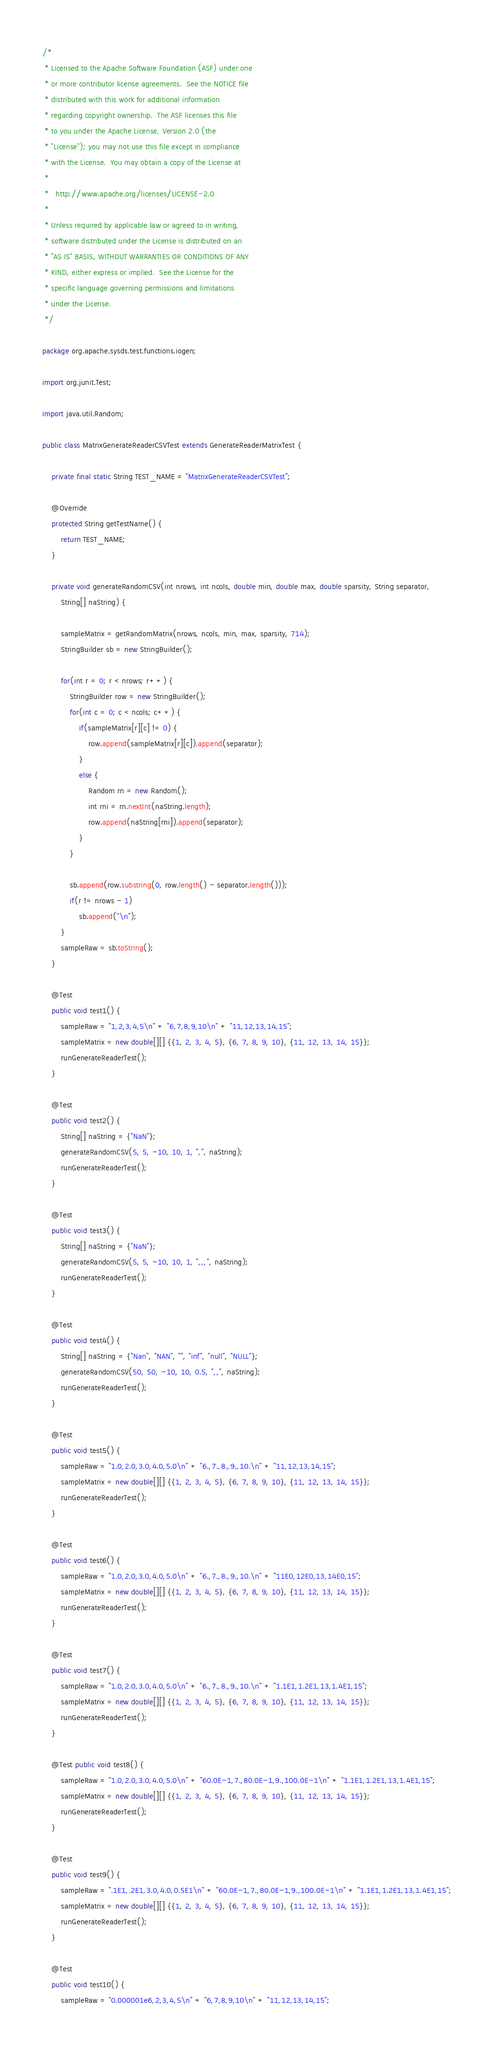Convert code to text. <code><loc_0><loc_0><loc_500><loc_500><_Java_>/*
 * Licensed to the Apache Software Foundation (ASF) under one
 * or more contributor license agreements.  See the NOTICE file
 * distributed with this work for additional information
 * regarding copyright ownership.  The ASF licenses this file
 * to you under the Apache License, Version 2.0 (the
 * "License"); you may not use this file except in compliance
 * with the License.  You may obtain a copy of the License at
 *
 *   http://www.apache.org/licenses/LICENSE-2.0
 *
 * Unless required by applicable law or agreed to in writing,
 * software distributed under the License is distributed on an
 * "AS IS" BASIS, WITHOUT WARRANTIES OR CONDITIONS OF ANY
 * KIND, either express or implied.  See the License for the
 * specific language governing permissions and limitations
 * under the License.
 */

package org.apache.sysds.test.functions.iogen;

import org.junit.Test;

import java.util.Random;

public class MatrixGenerateReaderCSVTest extends GenerateReaderMatrixTest {

	private final static String TEST_NAME = "MatrixGenerateReaderCSVTest";

	@Override
	protected String getTestName() {
		return TEST_NAME;
	}

	private void generateRandomCSV(int nrows, int ncols, double min, double max, double sparsity, String separator,
		String[] naString) {

		sampleMatrix = getRandomMatrix(nrows, ncols, min, max, sparsity, 714);
		StringBuilder sb = new StringBuilder();

		for(int r = 0; r < nrows; r++) {
			StringBuilder row = new StringBuilder();
			for(int c = 0; c < ncols; c++) {
				if(sampleMatrix[r][c] != 0) {
					row.append(sampleMatrix[r][c]).append(separator);
				}
				else {
					Random rn = new Random();
					int rni = rn.nextInt(naString.length);
					row.append(naString[rni]).append(separator);
				}
			}

			sb.append(row.substring(0, row.length() - separator.length()));
			if(r != nrows - 1)
				sb.append("\n");
		}
		sampleRaw = sb.toString();
	}

	@Test
	public void test1() {
		sampleRaw = "1,2,3,4,5\n" + "6,7,8,9,10\n" + "11,12,13,14,15";
		sampleMatrix = new double[][] {{1, 2, 3, 4, 5}, {6, 7, 8, 9, 10}, {11, 12, 13, 14, 15}};
		runGenerateReaderTest();
	}

	@Test
	public void test2() {
		String[] naString = {"NaN"};
		generateRandomCSV(5, 5, -10, 10, 1, ",", naString);
		runGenerateReaderTest();
	}

	@Test
	public void test3() {
		String[] naString = {"NaN"};
		generateRandomCSV(5, 5, -10, 10, 1, ",,,", naString);
		runGenerateReaderTest();
	}

	@Test
	public void test4() {
		String[] naString = {"Nan", "NAN", "", "inf", "null", "NULL"};
		generateRandomCSV(50, 50, -10, 10, 0.5, ",,", naString);
		runGenerateReaderTest();
	}

	@Test
	public void test5() {
		sampleRaw = "1.0,2.0,3.0,4.0,5.0\n" + "6.,7.,8.,9.,10.\n" + "11,12,13,14,15";
		sampleMatrix = new double[][] {{1, 2, 3, 4, 5}, {6, 7, 8, 9, 10}, {11, 12, 13, 14, 15}};
		runGenerateReaderTest();
	}

	@Test
	public void test6() {
		sampleRaw = "1.0,2.0,3.0,4.0,5.0\n" + "6.,7.,8.,9.,10.\n" + "11E0,12E0,13,14E0,15";
		sampleMatrix = new double[][] {{1, 2, 3, 4, 5}, {6, 7, 8, 9, 10}, {11, 12, 13, 14, 15}};
		runGenerateReaderTest();
	}

	@Test
	public void test7() {
		sampleRaw = "1.0,2.0,3.0,4.0,5.0\n" + "6.,7.,8.,9.,10.\n" + "1.1E1,1.2E1,13,1.4E1,15";
		sampleMatrix = new double[][] {{1, 2, 3, 4, 5}, {6, 7, 8, 9, 10}, {11, 12, 13, 14, 15}};
		runGenerateReaderTest();
	}

	@Test public void test8() {
		sampleRaw = "1.0,2.0,3.0,4.0,5.0\n" + "60.0E-1,7.,80.0E-1,9.,100.0E-1\n" + "1.1E1,1.2E1,13,1.4E1,15";
		sampleMatrix = new double[][] {{1, 2, 3, 4, 5}, {6, 7, 8, 9, 10}, {11, 12, 13, 14, 15}};
		runGenerateReaderTest();
	}

	@Test
	public void test9() {
		sampleRaw = ".1E1,.2E1,3.0,4.0,0.5E1\n" + "60.0E-1,7.,80.0E-1,9.,100.0E-1\n" + "1.1E1,1.2E1,13,1.4E1,15";
		sampleMatrix = new double[][] {{1, 2, 3, 4, 5}, {6, 7, 8, 9, 10}, {11, 12, 13, 14, 15}};
		runGenerateReaderTest();
	}

	@Test
	public void test10() {
		sampleRaw = "0.000001e6,2,3,4,5\n" + "6,7,8,9,10\n" + "11,12,13,14,15";</code> 